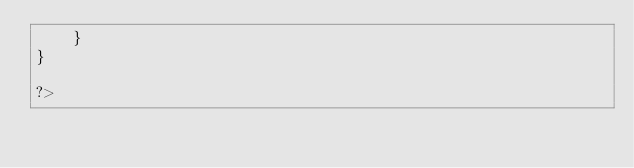Convert code to text. <code><loc_0><loc_0><loc_500><loc_500><_PHP_>    }
}

?></code> 